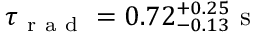<formula> <loc_0><loc_0><loc_500><loc_500>\tau _ { r a d } = 0 . 7 2 _ { - 0 . 1 3 } ^ { + 0 . 2 5 } s</formula> 